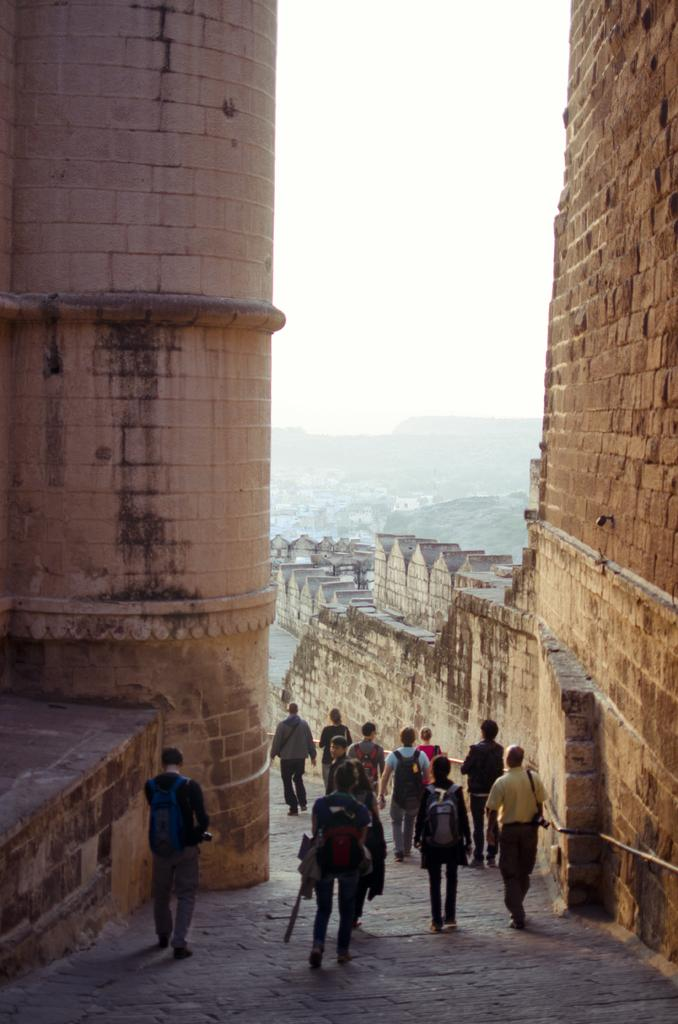How many people are in the image? There is a group of people in the image, but the exact number is not specified. What are the people in the image doing? The people are walking on a pathway in the image. What can be seen in the background of the image? There is a monument, buildings, hills, and a cloudy sky visible in the background. What type of quiver can be seen on the monument in the image? There is no quiver present on the monument in the image. How are the people in the image sorting the items they are carrying? The people in the image are not shown sorting any items; they are simply walking on a pathway. 